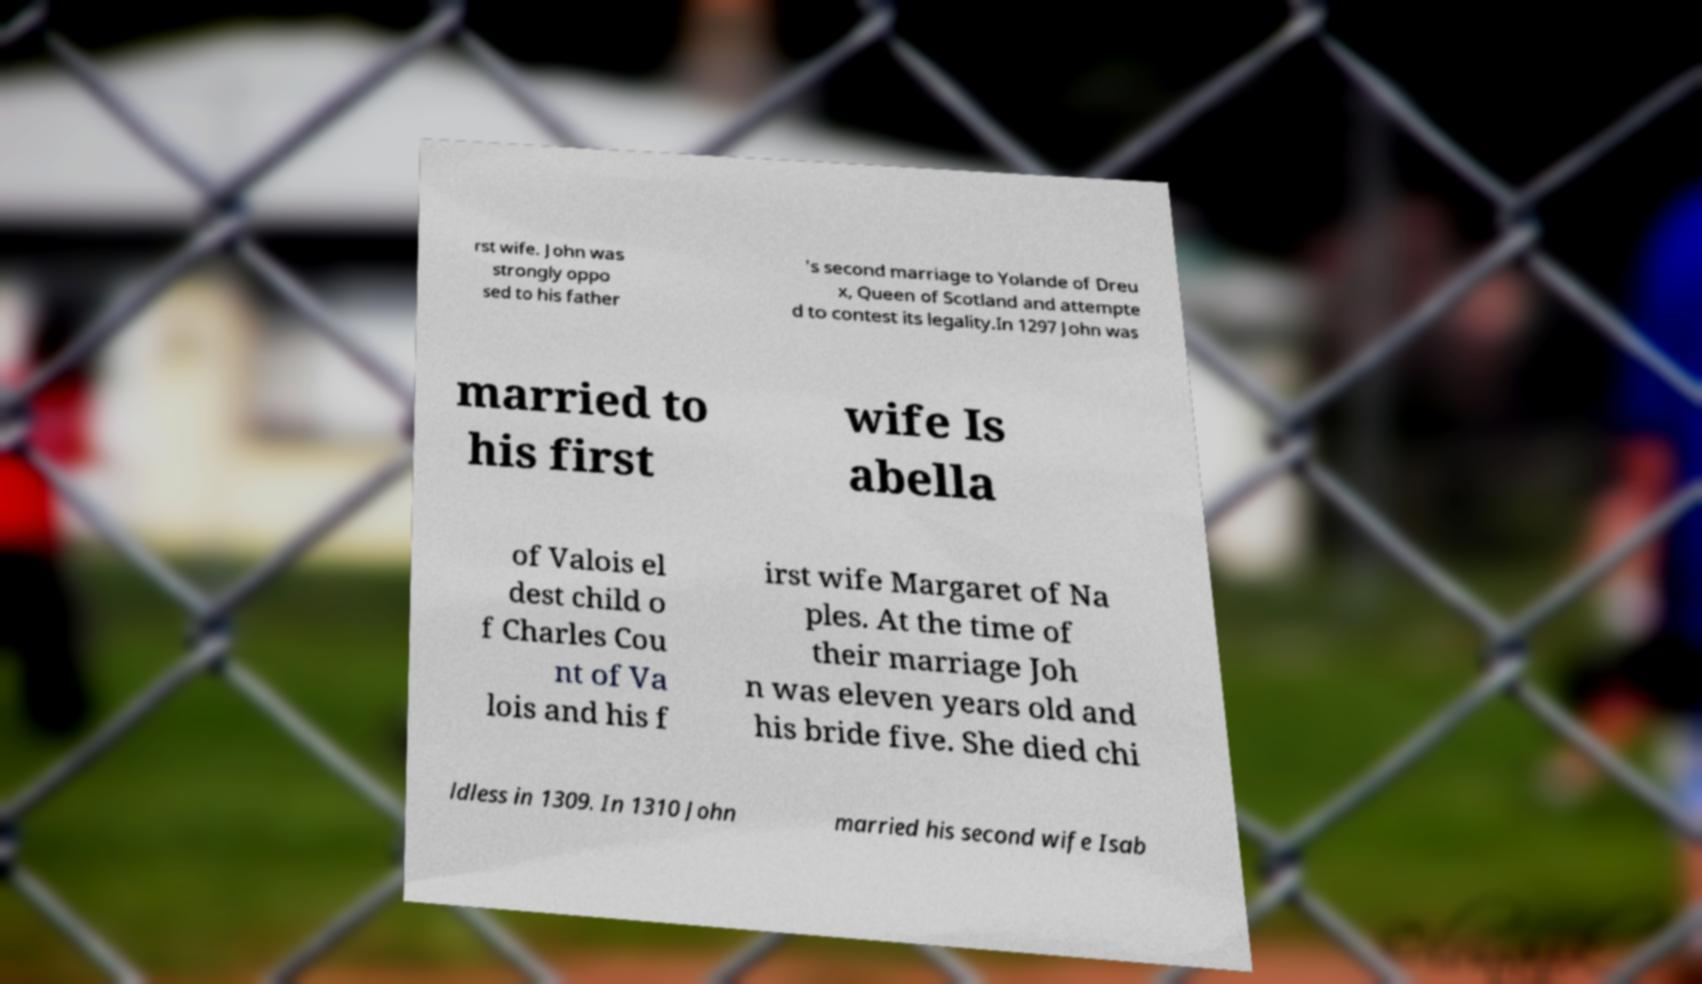Please read and relay the text visible in this image. What does it say? rst wife. John was strongly oppo sed to his father 's second marriage to Yolande of Dreu x, Queen of Scotland and attempte d to contest its legality.In 1297 John was married to his first wife Is abella of Valois el dest child o f Charles Cou nt of Va lois and his f irst wife Margaret of Na ples. At the time of their marriage Joh n was eleven years old and his bride five. She died chi ldless in 1309. In 1310 John married his second wife Isab 